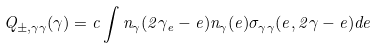<formula> <loc_0><loc_0><loc_500><loc_500>Q _ { \pm , \gamma \gamma } ( \gamma ) = c \int n _ { \gamma } ( 2 \gamma _ { e } - e ) n _ { \gamma } ( e ) \sigma _ { \gamma \gamma } ( e , 2 \gamma - e ) d e</formula> 